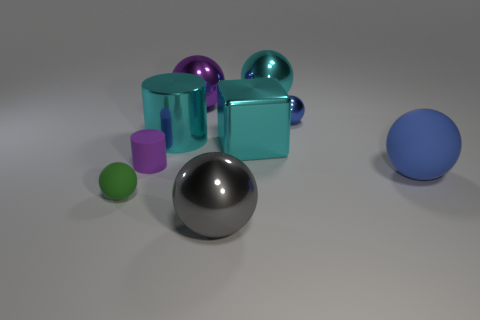Are there any cyan things of the same size as the gray metallic object?
Provide a succinct answer. Yes. Is the number of tiny things that are left of the tiny shiny ball the same as the number of large cyan blocks that are on the left side of the small green matte object?
Make the answer very short. No. Is the material of the big purple thing that is behind the big gray metal sphere the same as the purple thing in front of the large cyan cylinder?
Keep it short and to the point. No. What material is the large purple object?
Give a very brief answer. Metal. How many other objects are there of the same color as the cube?
Your answer should be very brief. 2. Is the color of the big cube the same as the shiny cylinder?
Your answer should be very brief. Yes. What number of gray metallic blocks are there?
Your answer should be very brief. 0. There is a large ball in front of the tiny ball that is in front of the metallic cylinder; what is it made of?
Offer a terse response. Metal. There is a blue object that is the same size as the green rubber object; what material is it?
Provide a short and direct response. Metal. Is the size of the cyan metallic thing behind the shiny cylinder the same as the rubber cylinder?
Offer a terse response. No. 